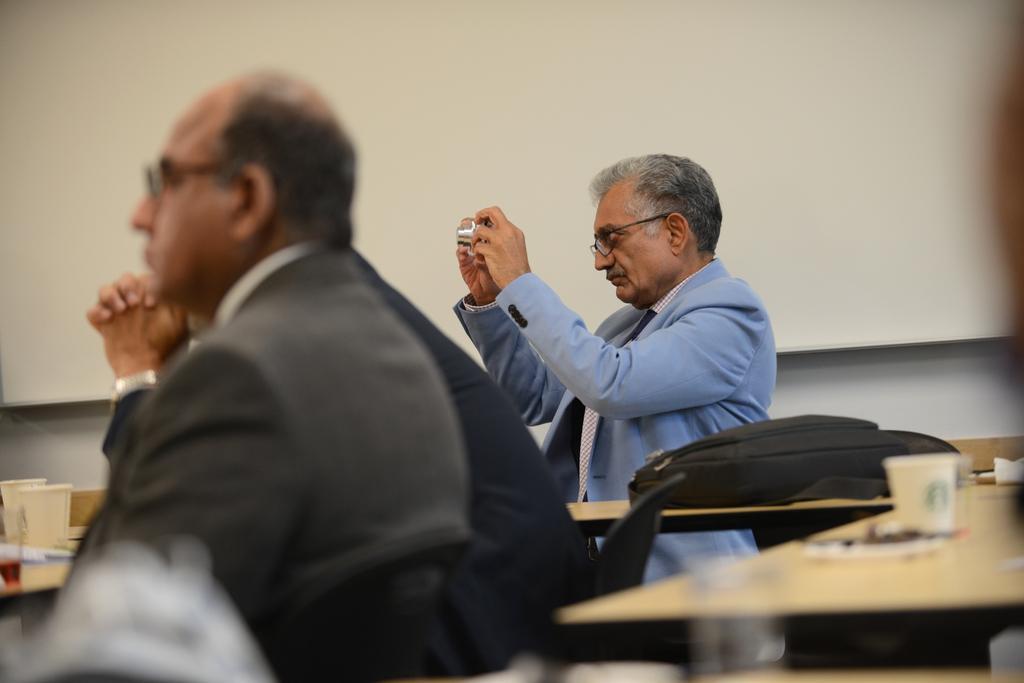Could you give a brief overview of what you see in this image? In this image in the centre there are two persons who are sitting and one person is holding a camera and also there are some tables. On the tables there are some cups, bag, papers and in the background there is a wall. 